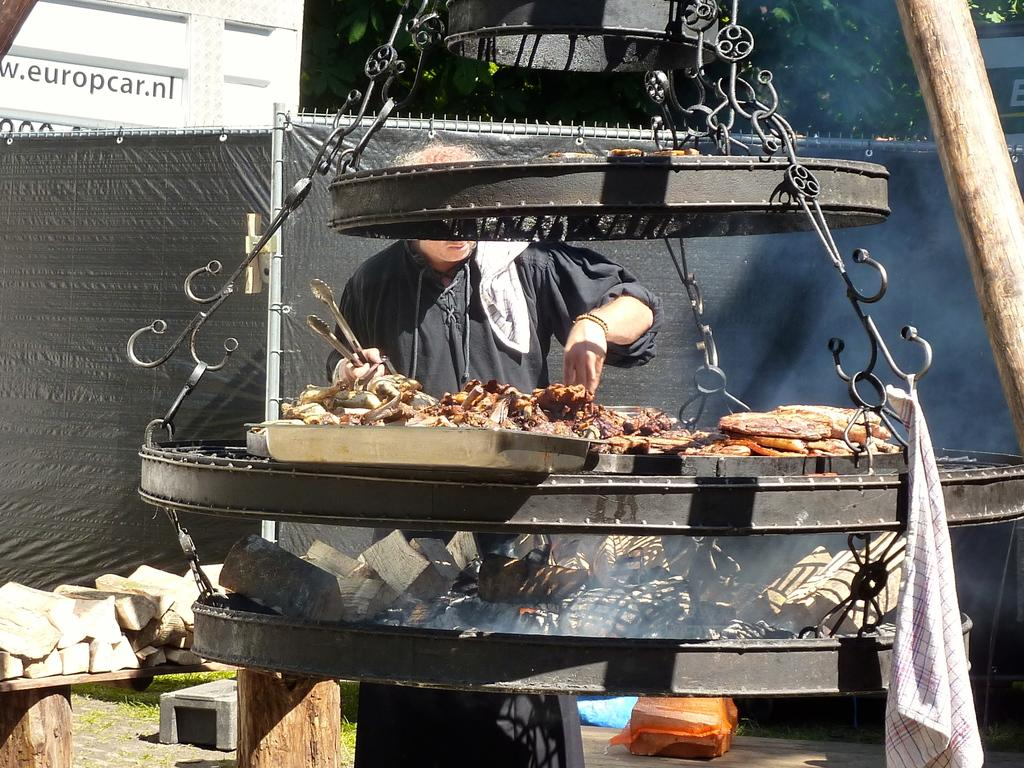<image>
Create a compact narrative representing the image presented. A billboard with europcar.nl on it looks over a man cooking. 